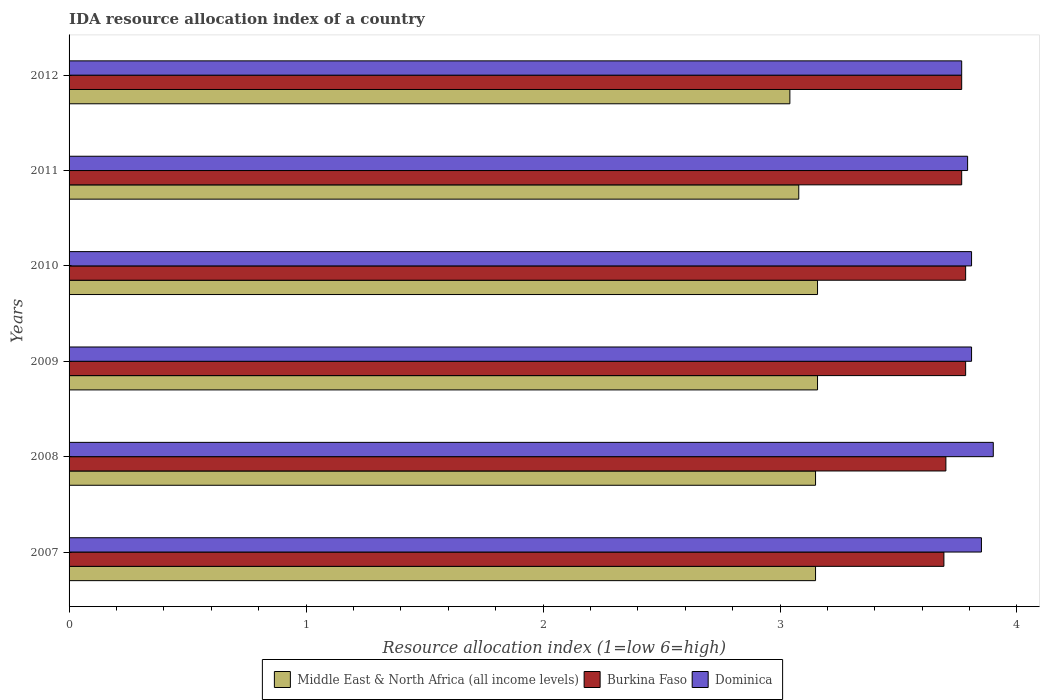How many different coloured bars are there?
Your answer should be compact. 3. Are the number of bars on each tick of the Y-axis equal?
Offer a very short reply. Yes. How many bars are there on the 2nd tick from the bottom?
Keep it short and to the point. 3. What is the label of the 2nd group of bars from the top?
Your response must be concise. 2011. What is the IDA resource allocation index in Middle East & North Africa (all income levels) in 2012?
Your answer should be very brief. 3.04. Across all years, what is the maximum IDA resource allocation index in Dominica?
Provide a succinct answer. 3.9. Across all years, what is the minimum IDA resource allocation index in Middle East & North Africa (all income levels)?
Offer a very short reply. 3.04. In which year was the IDA resource allocation index in Dominica minimum?
Your response must be concise. 2012. What is the total IDA resource allocation index in Burkina Faso in the graph?
Your response must be concise. 22.49. What is the difference between the IDA resource allocation index in Dominica in 2008 and that in 2010?
Make the answer very short. 0.09. What is the difference between the IDA resource allocation index in Middle East & North Africa (all income levels) in 2009 and the IDA resource allocation index in Burkina Faso in 2007?
Give a very brief answer. -0.53. What is the average IDA resource allocation index in Middle East & North Africa (all income levels) per year?
Keep it short and to the point. 3.12. In the year 2009, what is the difference between the IDA resource allocation index in Burkina Faso and IDA resource allocation index in Dominica?
Give a very brief answer. -0.02. In how many years, is the IDA resource allocation index in Dominica greater than 1.8 ?
Your answer should be very brief. 6. What is the ratio of the IDA resource allocation index in Burkina Faso in 2008 to that in 2009?
Provide a short and direct response. 0.98. Is the IDA resource allocation index in Burkina Faso in 2009 less than that in 2010?
Offer a terse response. No. What is the difference between the highest and the lowest IDA resource allocation index in Burkina Faso?
Your answer should be very brief. 0.09. Is the sum of the IDA resource allocation index in Burkina Faso in 2008 and 2010 greater than the maximum IDA resource allocation index in Dominica across all years?
Offer a very short reply. Yes. What does the 3rd bar from the top in 2009 represents?
Ensure brevity in your answer.  Middle East & North Africa (all income levels). What does the 1st bar from the bottom in 2008 represents?
Give a very brief answer. Middle East & North Africa (all income levels). Is it the case that in every year, the sum of the IDA resource allocation index in Dominica and IDA resource allocation index in Middle East & North Africa (all income levels) is greater than the IDA resource allocation index in Burkina Faso?
Offer a very short reply. Yes. Are all the bars in the graph horizontal?
Your answer should be compact. Yes. Are the values on the major ticks of X-axis written in scientific E-notation?
Provide a short and direct response. No. Does the graph contain any zero values?
Make the answer very short. No. Does the graph contain grids?
Ensure brevity in your answer.  No. How many legend labels are there?
Offer a very short reply. 3. What is the title of the graph?
Make the answer very short. IDA resource allocation index of a country. Does "Dominica" appear as one of the legend labels in the graph?
Ensure brevity in your answer.  Yes. What is the label or title of the X-axis?
Offer a terse response. Resource allocation index (1=low 6=high). What is the label or title of the Y-axis?
Make the answer very short. Years. What is the Resource allocation index (1=low 6=high) of Middle East & North Africa (all income levels) in 2007?
Offer a terse response. 3.15. What is the Resource allocation index (1=low 6=high) of Burkina Faso in 2007?
Your answer should be very brief. 3.69. What is the Resource allocation index (1=low 6=high) of Dominica in 2007?
Keep it short and to the point. 3.85. What is the Resource allocation index (1=low 6=high) in Middle East & North Africa (all income levels) in 2008?
Offer a terse response. 3.15. What is the Resource allocation index (1=low 6=high) of Burkina Faso in 2008?
Provide a succinct answer. 3.7. What is the Resource allocation index (1=low 6=high) in Middle East & North Africa (all income levels) in 2009?
Ensure brevity in your answer.  3.16. What is the Resource allocation index (1=low 6=high) in Burkina Faso in 2009?
Offer a terse response. 3.78. What is the Resource allocation index (1=low 6=high) in Dominica in 2009?
Your answer should be very brief. 3.81. What is the Resource allocation index (1=low 6=high) of Middle East & North Africa (all income levels) in 2010?
Offer a very short reply. 3.16. What is the Resource allocation index (1=low 6=high) of Burkina Faso in 2010?
Make the answer very short. 3.78. What is the Resource allocation index (1=low 6=high) of Dominica in 2010?
Ensure brevity in your answer.  3.81. What is the Resource allocation index (1=low 6=high) of Middle East & North Africa (all income levels) in 2011?
Ensure brevity in your answer.  3.08. What is the Resource allocation index (1=low 6=high) in Burkina Faso in 2011?
Your response must be concise. 3.77. What is the Resource allocation index (1=low 6=high) in Dominica in 2011?
Keep it short and to the point. 3.79. What is the Resource allocation index (1=low 6=high) in Middle East & North Africa (all income levels) in 2012?
Ensure brevity in your answer.  3.04. What is the Resource allocation index (1=low 6=high) in Burkina Faso in 2012?
Provide a succinct answer. 3.77. What is the Resource allocation index (1=low 6=high) of Dominica in 2012?
Keep it short and to the point. 3.77. Across all years, what is the maximum Resource allocation index (1=low 6=high) of Middle East & North Africa (all income levels)?
Keep it short and to the point. 3.16. Across all years, what is the maximum Resource allocation index (1=low 6=high) of Burkina Faso?
Provide a short and direct response. 3.78. Across all years, what is the maximum Resource allocation index (1=low 6=high) of Dominica?
Your answer should be very brief. 3.9. Across all years, what is the minimum Resource allocation index (1=low 6=high) in Middle East & North Africa (all income levels)?
Give a very brief answer. 3.04. Across all years, what is the minimum Resource allocation index (1=low 6=high) in Burkina Faso?
Your response must be concise. 3.69. Across all years, what is the minimum Resource allocation index (1=low 6=high) in Dominica?
Provide a short and direct response. 3.77. What is the total Resource allocation index (1=low 6=high) of Middle East & North Africa (all income levels) in the graph?
Make the answer very short. 18.74. What is the total Resource allocation index (1=low 6=high) in Burkina Faso in the graph?
Offer a terse response. 22.49. What is the total Resource allocation index (1=low 6=high) of Dominica in the graph?
Offer a terse response. 22.93. What is the difference between the Resource allocation index (1=low 6=high) in Burkina Faso in 2007 and that in 2008?
Your response must be concise. -0.01. What is the difference between the Resource allocation index (1=low 6=high) of Dominica in 2007 and that in 2008?
Your answer should be very brief. -0.05. What is the difference between the Resource allocation index (1=low 6=high) of Middle East & North Africa (all income levels) in 2007 and that in 2009?
Make the answer very short. -0.01. What is the difference between the Resource allocation index (1=low 6=high) in Burkina Faso in 2007 and that in 2009?
Your response must be concise. -0.09. What is the difference between the Resource allocation index (1=low 6=high) of Dominica in 2007 and that in 2009?
Offer a terse response. 0.04. What is the difference between the Resource allocation index (1=low 6=high) of Middle East & North Africa (all income levels) in 2007 and that in 2010?
Your answer should be very brief. -0.01. What is the difference between the Resource allocation index (1=low 6=high) of Burkina Faso in 2007 and that in 2010?
Your answer should be compact. -0.09. What is the difference between the Resource allocation index (1=low 6=high) in Dominica in 2007 and that in 2010?
Your response must be concise. 0.04. What is the difference between the Resource allocation index (1=low 6=high) of Middle East & North Africa (all income levels) in 2007 and that in 2011?
Ensure brevity in your answer.  0.07. What is the difference between the Resource allocation index (1=low 6=high) of Burkina Faso in 2007 and that in 2011?
Your response must be concise. -0.07. What is the difference between the Resource allocation index (1=low 6=high) in Dominica in 2007 and that in 2011?
Your response must be concise. 0.06. What is the difference between the Resource allocation index (1=low 6=high) in Middle East & North Africa (all income levels) in 2007 and that in 2012?
Your answer should be very brief. 0.11. What is the difference between the Resource allocation index (1=low 6=high) in Burkina Faso in 2007 and that in 2012?
Provide a succinct answer. -0.07. What is the difference between the Resource allocation index (1=low 6=high) in Dominica in 2007 and that in 2012?
Offer a terse response. 0.08. What is the difference between the Resource allocation index (1=low 6=high) of Middle East & North Africa (all income levels) in 2008 and that in 2009?
Your answer should be very brief. -0.01. What is the difference between the Resource allocation index (1=low 6=high) in Burkina Faso in 2008 and that in 2009?
Keep it short and to the point. -0.08. What is the difference between the Resource allocation index (1=low 6=high) in Dominica in 2008 and that in 2009?
Your answer should be very brief. 0.09. What is the difference between the Resource allocation index (1=low 6=high) of Middle East & North Africa (all income levels) in 2008 and that in 2010?
Ensure brevity in your answer.  -0.01. What is the difference between the Resource allocation index (1=low 6=high) in Burkina Faso in 2008 and that in 2010?
Offer a very short reply. -0.08. What is the difference between the Resource allocation index (1=low 6=high) of Dominica in 2008 and that in 2010?
Your answer should be compact. 0.09. What is the difference between the Resource allocation index (1=low 6=high) in Middle East & North Africa (all income levels) in 2008 and that in 2011?
Keep it short and to the point. 0.07. What is the difference between the Resource allocation index (1=low 6=high) of Burkina Faso in 2008 and that in 2011?
Offer a terse response. -0.07. What is the difference between the Resource allocation index (1=low 6=high) of Dominica in 2008 and that in 2011?
Ensure brevity in your answer.  0.11. What is the difference between the Resource allocation index (1=low 6=high) of Middle East & North Africa (all income levels) in 2008 and that in 2012?
Ensure brevity in your answer.  0.11. What is the difference between the Resource allocation index (1=low 6=high) of Burkina Faso in 2008 and that in 2012?
Provide a short and direct response. -0.07. What is the difference between the Resource allocation index (1=low 6=high) in Dominica in 2008 and that in 2012?
Provide a succinct answer. 0.13. What is the difference between the Resource allocation index (1=low 6=high) in Middle East & North Africa (all income levels) in 2009 and that in 2010?
Ensure brevity in your answer.  0. What is the difference between the Resource allocation index (1=low 6=high) in Middle East & North Africa (all income levels) in 2009 and that in 2011?
Your response must be concise. 0.08. What is the difference between the Resource allocation index (1=low 6=high) in Burkina Faso in 2009 and that in 2011?
Keep it short and to the point. 0.02. What is the difference between the Resource allocation index (1=low 6=high) in Dominica in 2009 and that in 2011?
Make the answer very short. 0.02. What is the difference between the Resource allocation index (1=low 6=high) of Middle East & North Africa (all income levels) in 2009 and that in 2012?
Your answer should be very brief. 0.12. What is the difference between the Resource allocation index (1=low 6=high) in Burkina Faso in 2009 and that in 2012?
Offer a very short reply. 0.02. What is the difference between the Resource allocation index (1=low 6=high) of Dominica in 2009 and that in 2012?
Your response must be concise. 0.04. What is the difference between the Resource allocation index (1=low 6=high) in Middle East & North Africa (all income levels) in 2010 and that in 2011?
Your answer should be very brief. 0.08. What is the difference between the Resource allocation index (1=low 6=high) in Burkina Faso in 2010 and that in 2011?
Keep it short and to the point. 0.02. What is the difference between the Resource allocation index (1=low 6=high) in Dominica in 2010 and that in 2011?
Your answer should be compact. 0.02. What is the difference between the Resource allocation index (1=low 6=high) in Middle East & North Africa (all income levels) in 2010 and that in 2012?
Provide a short and direct response. 0.12. What is the difference between the Resource allocation index (1=low 6=high) in Burkina Faso in 2010 and that in 2012?
Your answer should be compact. 0.02. What is the difference between the Resource allocation index (1=low 6=high) of Dominica in 2010 and that in 2012?
Provide a short and direct response. 0.04. What is the difference between the Resource allocation index (1=low 6=high) of Middle East & North Africa (all income levels) in 2011 and that in 2012?
Make the answer very short. 0.04. What is the difference between the Resource allocation index (1=low 6=high) in Dominica in 2011 and that in 2012?
Give a very brief answer. 0.03. What is the difference between the Resource allocation index (1=low 6=high) in Middle East & North Africa (all income levels) in 2007 and the Resource allocation index (1=low 6=high) in Burkina Faso in 2008?
Provide a short and direct response. -0.55. What is the difference between the Resource allocation index (1=low 6=high) in Middle East & North Africa (all income levels) in 2007 and the Resource allocation index (1=low 6=high) in Dominica in 2008?
Make the answer very short. -0.75. What is the difference between the Resource allocation index (1=low 6=high) in Burkina Faso in 2007 and the Resource allocation index (1=low 6=high) in Dominica in 2008?
Give a very brief answer. -0.21. What is the difference between the Resource allocation index (1=low 6=high) in Middle East & North Africa (all income levels) in 2007 and the Resource allocation index (1=low 6=high) in Burkina Faso in 2009?
Ensure brevity in your answer.  -0.63. What is the difference between the Resource allocation index (1=low 6=high) of Middle East & North Africa (all income levels) in 2007 and the Resource allocation index (1=low 6=high) of Dominica in 2009?
Give a very brief answer. -0.66. What is the difference between the Resource allocation index (1=low 6=high) in Burkina Faso in 2007 and the Resource allocation index (1=low 6=high) in Dominica in 2009?
Keep it short and to the point. -0.12. What is the difference between the Resource allocation index (1=low 6=high) in Middle East & North Africa (all income levels) in 2007 and the Resource allocation index (1=low 6=high) in Burkina Faso in 2010?
Ensure brevity in your answer.  -0.63. What is the difference between the Resource allocation index (1=low 6=high) in Middle East & North Africa (all income levels) in 2007 and the Resource allocation index (1=low 6=high) in Dominica in 2010?
Offer a very short reply. -0.66. What is the difference between the Resource allocation index (1=low 6=high) of Burkina Faso in 2007 and the Resource allocation index (1=low 6=high) of Dominica in 2010?
Provide a short and direct response. -0.12. What is the difference between the Resource allocation index (1=low 6=high) in Middle East & North Africa (all income levels) in 2007 and the Resource allocation index (1=low 6=high) in Burkina Faso in 2011?
Keep it short and to the point. -0.62. What is the difference between the Resource allocation index (1=low 6=high) of Middle East & North Africa (all income levels) in 2007 and the Resource allocation index (1=low 6=high) of Dominica in 2011?
Your answer should be compact. -0.64. What is the difference between the Resource allocation index (1=low 6=high) in Middle East & North Africa (all income levels) in 2007 and the Resource allocation index (1=low 6=high) in Burkina Faso in 2012?
Provide a succinct answer. -0.62. What is the difference between the Resource allocation index (1=low 6=high) of Middle East & North Africa (all income levels) in 2007 and the Resource allocation index (1=low 6=high) of Dominica in 2012?
Your answer should be very brief. -0.62. What is the difference between the Resource allocation index (1=low 6=high) in Burkina Faso in 2007 and the Resource allocation index (1=low 6=high) in Dominica in 2012?
Provide a succinct answer. -0.07. What is the difference between the Resource allocation index (1=low 6=high) in Middle East & North Africa (all income levels) in 2008 and the Resource allocation index (1=low 6=high) in Burkina Faso in 2009?
Your response must be concise. -0.63. What is the difference between the Resource allocation index (1=low 6=high) of Middle East & North Africa (all income levels) in 2008 and the Resource allocation index (1=low 6=high) of Dominica in 2009?
Give a very brief answer. -0.66. What is the difference between the Resource allocation index (1=low 6=high) of Burkina Faso in 2008 and the Resource allocation index (1=low 6=high) of Dominica in 2009?
Make the answer very short. -0.11. What is the difference between the Resource allocation index (1=low 6=high) of Middle East & North Africa (all income levels) in 2008 and the Resource allocation index (1=low 6=high) of Burkina Faso in 2010?
Make the answer very short. -0.63. What is the difference between the Resource allocation index (1=low 6=high) in Middle East & North Africa (all income levels) in 2008 and the Resource allocation index (1=low 6=high) in Dominica in 2010?
Give a very brief answer. -0.66. What is the difference between the Resource allocation index (1=low 6=high) in Burkina Faso in 2008 and the Resource allocation index (1=low 6=high) in Dominica in 2010?
Your answer should be compact. -0.11. What is the difference between the Resource allocation index (1=low 6=high) of Middle East & North Africa (all income levels) in 2008 and the Resource allocation index (1=low 6=high) of Burkina Faso in 2011?
Make the answer very short. -0.62. What is the difference between the Resource allocation index (1=low 6=high) of Middle East & North Africa (all income levels) in 2008 and the Resource allocation index (1=low 6=high) of Dominica in 2011?
Offer a very short reply. -0.64. What is the difference between the Resource allocation index (1=low 6=high) of Burkina Faso in 2008 and the Resource allocation index (1=low 6=high) of Dominica in 2011?
Keep it short and to the point. -0.09. What is the difference between the Resource allocation index (1=low 6=high) of Middle East & North Africa (all income levels) in 2008 and the Resource allocation index (1=low 6=high) of Burkina Faso in 2012?
Your answer should be compact. -0.62. What is the difference between the Resource allocation index (1=low 6=high) in Middle East & North Africa (all income levels) in 2008 and the Resource allocation index (1=low 6=high) in Dominica in 2012?
Offer a very short reply. -0.62. What is the difference between the Resource allocation index (1=low 6=high) in Burkina Faso in 2008 and the Resource allocation index (1=low 6=high) in Dominica in 2012?
Keep it short and to the point. -0.07. What is the difference between the Resource allocation index (1=low 6=high) of Middle East & North Africa (all income levels) in 2009 and the Resource allocation index (1=low 6=high) of Burkina Faso in 2010?
Give a very brief answer. -0.62. What is the difference between the Resource allocation index (1=low 6=high) of Middle East & North Africa (all income levels) in 2009 and the Resource allocation index (1=low 6=high) of Dominica in 2010?
Give a very brief answer. -0.65. What is the difference between the Resource allocation index (1=low 6=high) in Burkina Faso in 2009 and the Resource allocation index (1=low 6=high) in Dominica in 2010?
Ensure brevity in your answer.  -0.03. What is the difference between the Resource allocation index (1=low 6=high) in Middle East & North Africa (all income levels) in 2009 and the Resource allocation index (1=low 6=high) in Burkina Faso in 2011?
Provide a succinct answer. -0.61. What is the difference between the Resource allocation index (1=low 6=high) in Middle East & North Africa (all income levels) in 2009 and the Resource allocation index (1=low 6=high) in Dominica in 2011?
Provide a short and direct response. -0.63. What is the difference between the Resource allocation index (1=low 6=high) in Burkina Faso in 2009 and the Resource allocation index (1=low 6=high) in Dominica in 2011?
Your response must be concise. -0.01. What is the difference between the Resource allocation index (1=low 6=high) in Middle East & North Africa (all income levels) in 2009 and the Resource allocation index (1=low 6=high) in Burkina Faso in 2012?
Your answer should be compact. -0.61. What is the difference between the Resource allocation index (1=low 6=high) in Middle East & North Africa (all income levels) in 2009 and the Resource allocation index (1=low 6=high) in Dominica in 2012?
Offer a terse response. -0.61. What is the difference between the Resource allocation index (1=low 6=high) of Burkina Faso in 2009 and the Resource allocation index (1=low 6=high) of Dominica in 2012?
Provide a short and direct response. 0.02. What is the difference between the Resource allocation index (1=low 6=high) in Middle East & North Africa (all income levels) in 2010 and the Resource allocation index (1=low 6=high) in Burkina Faso in 2011?
Offer a terse response. -0.61. What is the difference between the Resource allocation index (1=low 6=high) in Middle East & North Africa (all income levels) in 2010 and the Resource allocation index (1=low 6=high) in Dominica in 2011?
Provide a succinct answer. -0.63. What is the difference between the Resource allocation index (1=low 6=high) in Burkina Faso in 2010 and the Resource allocation index (1=low 6=high) in Dominica in 2011?
Provide a short and direct response. -0.01. What is the difference between the Resource allocation index (1=low 6=high) in Middle East & North Africa (all income levels) in 2010 and the Resource allocation index (1=low 6=high) in Burkina Faso in 2012?
Ensure brevity in your answer.  -0.61. What is the difference between the Resource allocation index (1=low 6=high) in Middle East & North Africa (all income levels) in 2010 and the Resource allocation index (1=low 6=high) in Dominica in 2012?
Your answer should be compact. -0.61. What is the difference between the Resource allocation index (1=low 6=high) of Burkina Faso in 2010 and the Resource allocation index (1=low 6=high) of Dominica in 2012?
Provide a short and direct response. 0.02. What is the difference between the Resource allocation index (1=low 6=high) in Middle East & North Africa (all income levels) in 2011 and the Resource allocation index (1=low 6=high) in Burkina Faso in 2012?
Provide a succinct answer. -0.69. What is the difference between the Resource allocation index (1=low 6=high) in Middle East & North Africa (all income levels) in 2011 and the Resource allocation index (1=low 6=high) in Dominica in 2012?
Offer a very short reply. -0.69. What is the average Resource allocation index (1=low 6=high) of Middle East & North Africa (all income levels) per year?
Make the answer very short. 3.12. What is the average Resource allocation index (1=low 6=high) in Burkina Faso per year?
Offer a very short reply. 3.75. What is the average Resource allocation index (1=low 6=high) in Dominica per year?
Give a very brief answer. 3.82. In the year 2007, what is the difference between the Resource allocation index (1=low 6=high) of Middle East & North Africa (all income levels) and Resource allocation index (1=low 6=high) of Burkina Faso?
Provide a short and direct response. -0.54. In the year 2007, what is the difference between the Resource allocation index (1=low 6=high) in Burkina Faso and Resource allocation index (1=low 6=high) in Dominica?
Provide a succinct answer. -0.16. In the year 2008, what is the difference between the Resource allocation index (1=low 6=high) in Middle East & North Africa (all income levels) and Resource allocation index (1=low 6=high) in Burkina Faso?
Keep it short and to the point. -0.55. In the year 2008, what is the difference between the Resource allocation index (1=low 6=high) of Middle East & North Africa (all income levels) and Resource allocation index (1=low 6=high) of Dominica?
Keep it short and to the point. -0.75. In the year 2009, what is the difference between the Resource allocation index (1=low 6=high) of Middle East & North Africa (all income levels) and Resource allocation index (1=low 6=high) of Burkina Faso?
Your answer should be very brief. -0.62. In the year 2009, what is the difference between the Resource allocation index (1=low 6=high) of Middle East & North Africa (all income levels) and Resource allocation index (1=low 6=high) of Dominica?
Your response must be concise. -0.65. In the year 2009, what is the difference between the Resource allocation index (1=low 6=high) in Burkina Faso and Resource allocation index (1=low 6=high) in Dominica?
Provide a short and direct response. -0.03. In the year 2010, what is the difference between the Resource allocation index (1=low 6=high) of Middle East & North Africa (all income levels) and Resource allocation index (1=low 6=high) of Burkina Faso?
Your answer should be compact. -0.62. In the year 2010, what is the difference between the Resource allocation index (1=low 6=high) in Middle East & North Africa (all income levels) and Resource allocation index (1=low 6=high) in Dominica?
Make the answer very short. -0.65. In the year 2010, what is the difference between the Resource allocation index (1=low 6=high) of Burkina Faso and Resource allocation index (1=low 6=high) of Dominica?
Your response must be concise. -0.03. In the year 2011, what is the difference between the Resource allocation index (1=low 6=high) in Middle East & North Africa (all income levels) and Resource allocation index (1=low 6=high) in Burkina Faso?
Give a very brief answer. -0.69. In the year 2011, what is the difference between the Resource allocation index (1=low 6=high) of Middle East & North Africa (all income levels) and Resource allocation index (1=low 6=high) of Dominica?
Your answer should be compact. -0.71. In the year 2011, what is the difference between the Resource allocation index (1=low 6=high) in Burkina Faso and Resource allocation index (1=low 6=high) in Dominica?
Provide a short and direct response. -0.03. In the year 2012, what is the difference between the Resource allocation index (1=low 6=high) of Middle East & North Africa (all income levels) and Resource allocation index (1=low 6=high) of Burkina Faso?
Offer a very short reply. -0.72. In the year 2012, what is the difference between the Resource allocation index (1=low 6=high) in Middle East & North Africa (all income levels) and Resource allocation index (1=low 6=high) in Dominica?
Keep it short and to the point. -0.72. In the year 2012, what is the difference between the Resource allocation index (1=low 6=high) of Burkina Faso and Resource allocation index (1=low 6=high) of Dominica?
Offer a terse response. 0. What is the ratio of the Resource allocation index (1=low 6=high) of Middle East & North Africa (all income levels) in 2007 to that in 2008?
Give a very brief answer. 1. What is the ratio of the Resource allocation index (1=low 6=high) in Burkina Faso in 2007 to that in 2008?
Your response must be concise. 1. What is the ratio of the Resource allocation index (1=low 6=high) of Dominica in 2007 to that in 2008?
Your answer should be very brief. 0.99. What is the ratio of the Resource allocation index (1=low 6=high) in Burkina Faso in 2007 to that in 2009?
Offer a terse response. 0.98. What is the ratio of the Resource allocation index (1=low 6=high) of Dominica in 2007 to that in 2009?
Your answer should be compact. 1.01. What is the ratio of the Resource allocation index (1=low 6=high) in Middle East & North Africa (all income levels) in 2007 to that in 2010?
Your answer should be very brief. 1. What is the ratio of the Resource allocation index (1=low 6=high) of Burkina Faso in 2007 to that in 2010?
Your answer should be compact. 0.98. What is the ratio of the Resource allocation index (1=low 6=high) in Dominica in 2007 to that in 2010?
Keep it short and to the point. 1.01. What is the ratio of the Resource allocation index (1=low 6=high) of Burkina Faso in 2007 to that in 2011?
Provide a succinct answer. 0.98. What is the ratio of the Resource allocation index (1=low 6=high) in Dominica in 2007 to that in 2011?
Offer a very short reply. 1.02. What is the ratio of the Resource allocation index (1=low 6=high) of Middle East & North Africa (all income levels) in 2007 to that in 2012?
Your answer should be compact. 1.04. What is the ratio of the Resource allocation index (1=low 6=high) in Burkina Faso in 2007 to that in 2012?
Ensure brevity in your answer.  0.98. What is the ratio of the Resource allocation index (1=low 6=high) of Dominica in 2007 to that in 2012?
Provide a short and direct response. 1.02. What is the ratio of the Resource allocation index (1=low 6=high) of Burkina Faso in 2008 to that in 2009?
Provide a short and direct response. 0.98. What is the ratio of the Resource allocation index (1=low 6=high) of Dominica in 2008 to that in 2009?
Your response must be concise. 1.02. What is the ratio of the Resource allocation index (1=low 6=high) of Burkina Faso in 2008 to that in 2010?
Give a very brief answer. 0.98. What is the ratio of the Resource allocation index (1=low 6=high) in Dominica in 2008 to that in 2010?
Ensure brevity in your answer.  1.02. What is the ratio of the Resource allocation index (1=low 6=high) of Burkina Faso in 2008 to that in 2011?
Ensure brevity in your answer.  0.98. What is the ratio of the Resource allocation index (1=low 6=high) in Dominica in 2008 to that in 2011?
Keep it short and to the point. 1.03. What is the ratio of the Resource allocation index (1=low 6=high) of Middle East & North Africa (all income levels) in 2008 to that in 2012?
Make the answer very short. 1.04. What is the ratio of the Resource allocation index (1=low 6=high) in Burkina Faso in 2008 to that in 2012?
Give a very brief answer. 0.98. What is the ratio of the Resource allocation index (1=low 6=high) in Dominica in 2008 to that in 2012?
Make the answer very short. 1.04. What is the ratio of the Resource allocation index (1=low 6=high) of Middle East & North Africa (all income levels) in 2009 to that in 2011?
Give a very brief answer. 1.03. What is the ratio of the Resource allocation index (1=low 6=high) of Middle East & North Africa (all income levels) in 2009 to that in 2012?
Offer a very short reply. 1.04. What is the ratio of the Resource allocation index (1=low 6=high) in Dominica in 2009 to that in 2012?
Your response must be concise. 1.01. What is the ratio of the Resource allocation index (1=low 6=high) of Middle East & North Africa (all income levels) in 2010 to that in 2011?
Offer a terse response. 1.03. What is the ratio of the Resource allocation index (1=low 6=high) in Burkina Faso in 2010 to that in 2011?
Your response must be concise. 1. What is the ratio of the Resource allocation index (1=low 6=high) of Middle East & North Africa (all income levels) in 2010 to that in 2012?
Provide a short and direct response. 1.04. What is the ratio of the Resource allocation index (1=low 6=high) of Burkina Faso in 2010 to that in 2012?
Keep it short and to the point. 1. What is the ratio of the Resource allocation index (1=low 6=high) of Dominica in 2010 to that in 2012?
Provide a short and direct response. 1.01. What is the ratio of the Resource allocation index (1=low 6=high) in Middle East & North Africa (all income levels) in 2011 to that in 2012?
Your response must be concise. 1.01. What is the ratio of the Resource allocation index (1=low 6=high) of Burkina Faso in 2011 to that in 2012?
Ensure brevity in your answer.  1. What is the ratio of the Resource allocation index (1=low 6=high) in Dominica in 2011 to that in 2012?
Ensure brevity in your answer.  1.01. What is the difference between the highest and the lowest Resource allocation index (1=low 6=high) in Middle East & North Africa (all income levels)?
Give a very brief answer. 0.12. What is the difference between the highest and the lowest Resource allocation index (1=low 6=high) of Burkina Faso?
Keep it short and to the point. 0.09. What is the difference between the highest and the lowest Resource allocation index (1=low 6=high) of Dominica?
Provide a succinct answer. 0.13. 